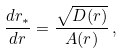Convert formula to latex. <formula><loc_0><loc_0><loc_500><loc_500>\frac { d r _ { * } } { d r } = \frac { \sqrt { D ( r ) } } { A ( r ) } \, ,</formula> 